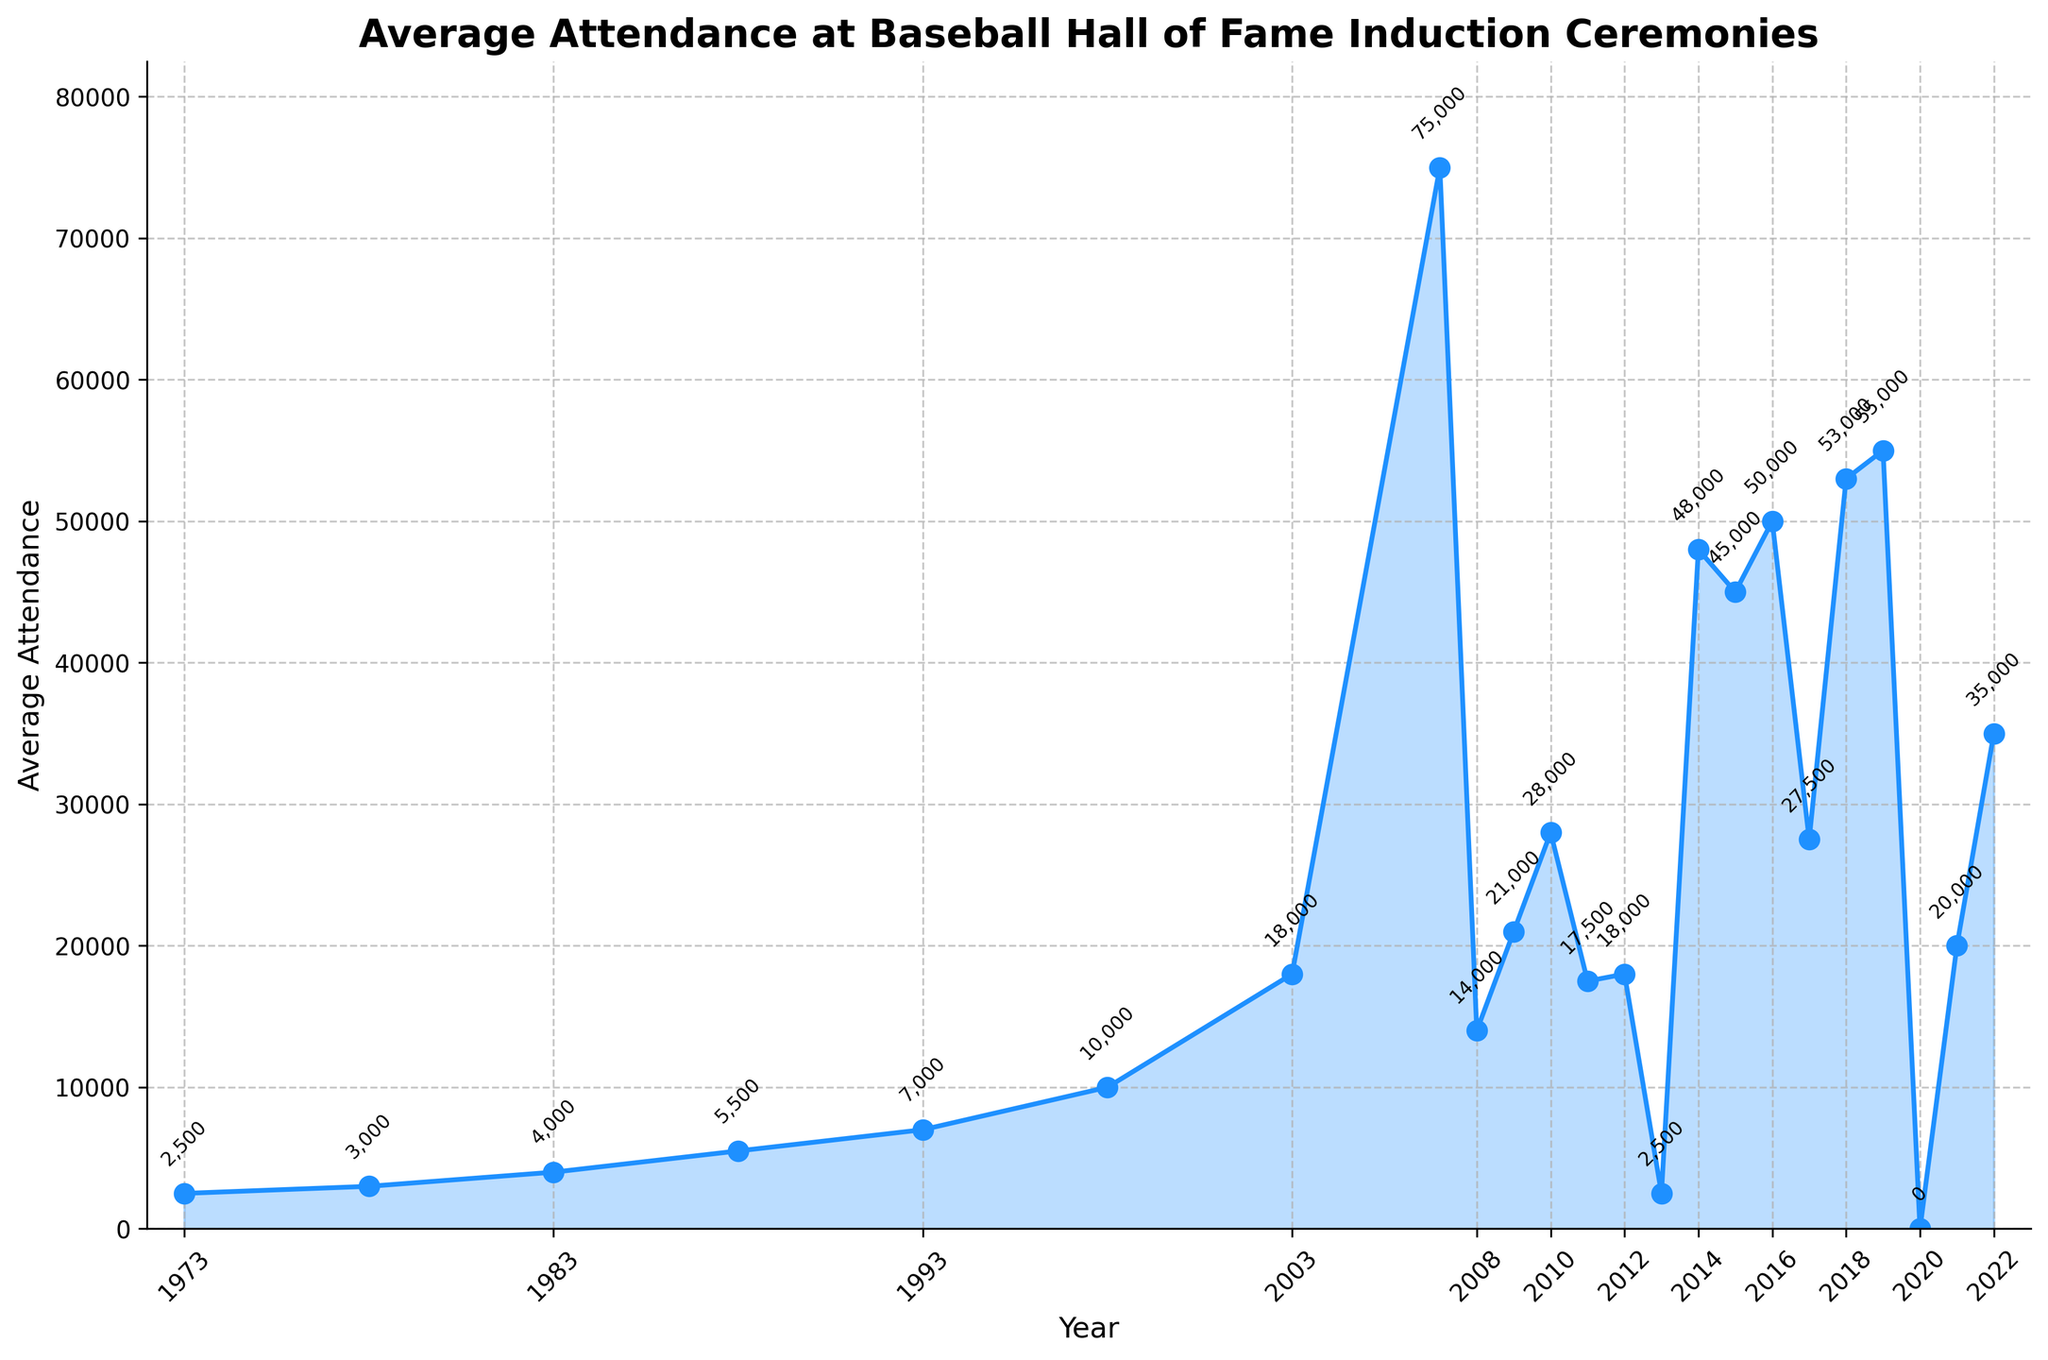What was the average attendance in 2007? The figure shows data points for each year with the corresponding average attendance. For 2007, the data point is marked, and the annotated value beside it is 75,000.
Answer: 75,000 How does the average attendance in 2014 compare to 2015? By looking at the data points for 2014 and 2015, we can see that the attendance in 2014 was 48,000 and in 2015 it was 45,000. 2014's attendance is slightly higher by 3,000.
Answer: 2014 is higher by 3,000 What is the percentage change in average attendance from 1973 to 2003? In 1973, the average attendance was 2,500, and in 2003, it was 18,000. The percentage change can be calculated as ((18,000 - 2,500) / 2,500) * 100 = 620%.
Answer: 620% Which year experienced the highest average attendance? The highest point on the chart is in 2007, where the average attendance reached 75,000.
Answer: 2007 What was the attendance trend between 2007 and 2013? From the figure, 2007 had the highest attendance at 75,000. In 2009, attendance dropped to 21,000, and after fluctuating slightly, it decreased significantly to 2,500 in 2013.
Answer: Downward trend Identify the years when the attendance was exactly 18,000. The chart indicates that the average attendance was 18,000 in both 2003 and 2012.
Answer: 2003 and 2012 How did the attendance change from 2016 to 2017? The attendance in 2016 was 50,000, and in 2017, it decreased to 27,500. This shows a drop of 22,500.
Answer: Decreased by 22,500 What was the average attendance in 2020 and why? The chart shows that 2020 had an average attendance of 0, indicated by the data point and annotation.
Answer: 0 due to likely cancellation of the event What is the range of average attendance values depicted in the figure? The range is found by subtracting the smallest value (0 in 2020) from the largest value (75,000 in 2007). 75,000 - 0 = 75,000.
Answer: 75,000 Compare the average attendance in 1998 and 2018. From the data points, in 1998, the attendance was 10,000, while in 2018, it was 53,000. Therefore, 2018 saw an attendance increase of 43,000 compared to 1998.
Answer: 2018 higher by 43,000 